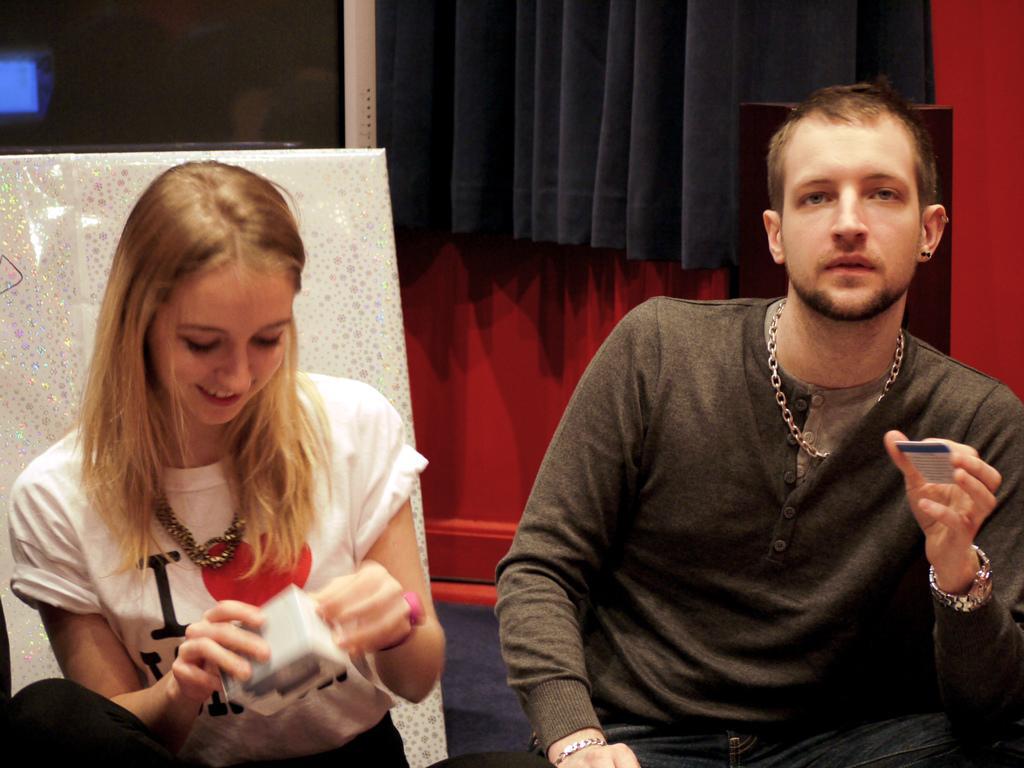Describe this image in one or two sentences. In the foreground of this picture, there is a man sitting and holding a card in his hand and there is a woman sitting and holding a box like an object in her hand. In the background, there is a red wall, black curtain and a screen of an object. 